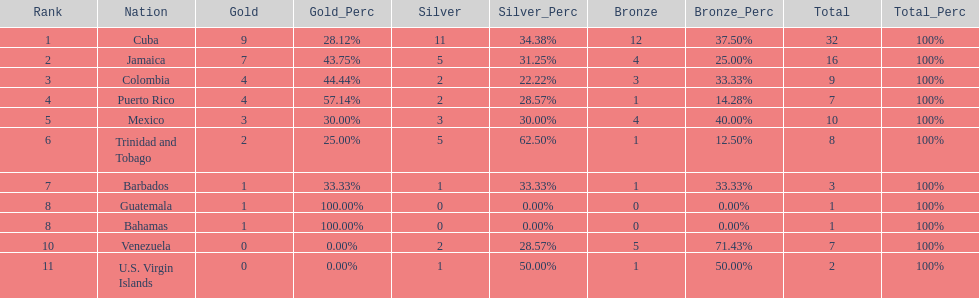The nation before mexico in the table Puerto Rico. 